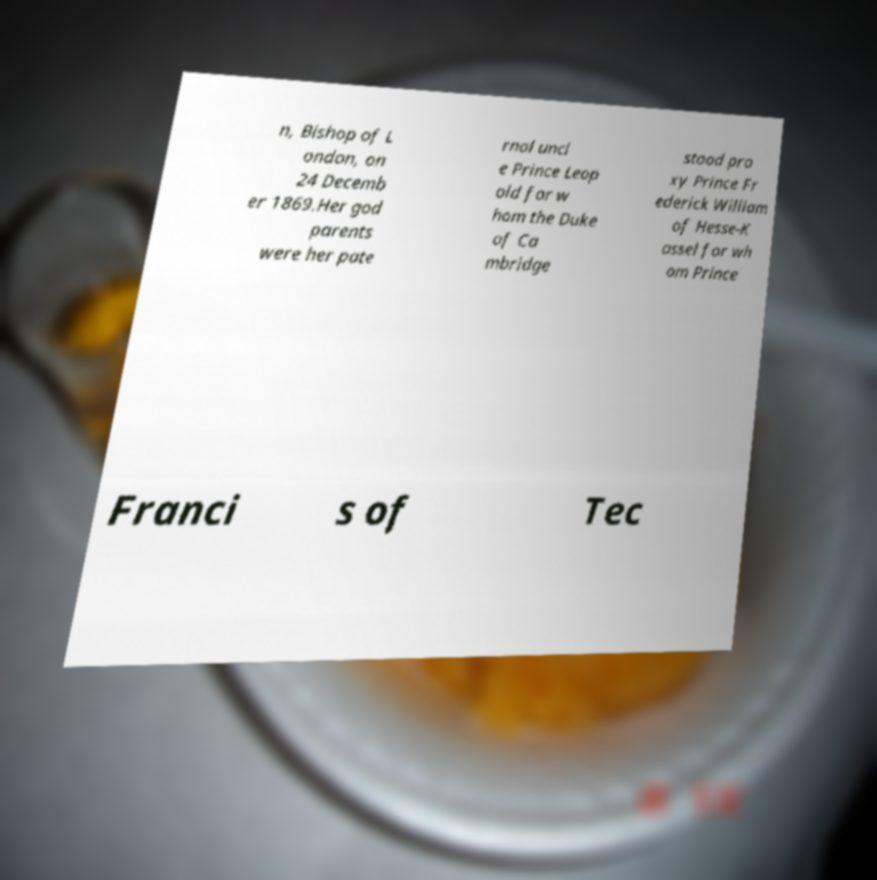Please read and relay the text visible in this image. What does it say? n, Bishop of L ondon, on 24 Decemb er 1869.Her god parents were her pate rnal uncl e Prince Leop old for w hom the Duke of Ca mbridge stood pro xy Prince Fr ederick William of Hesse-K assel for wh om Prince Franci s of Tec 